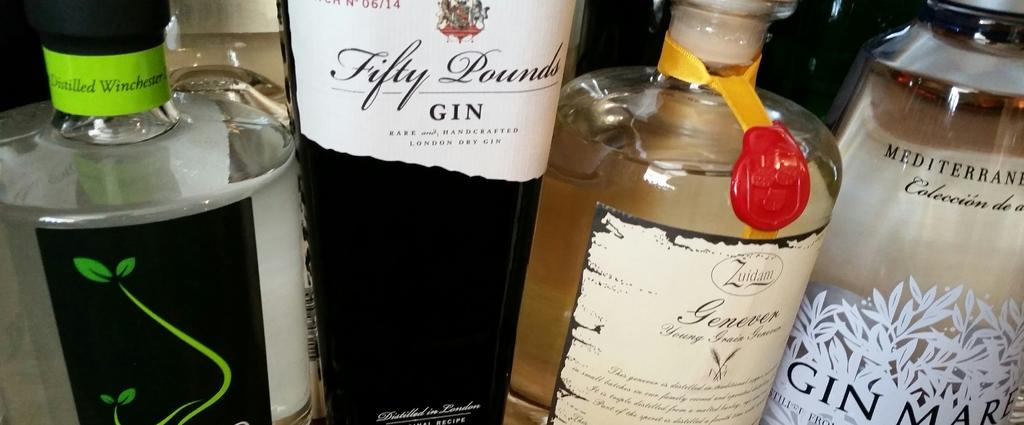<image>
Create a compact narrative representing the image presented. A bottle of fifty pounds gin sits next to other bottles on a table. 